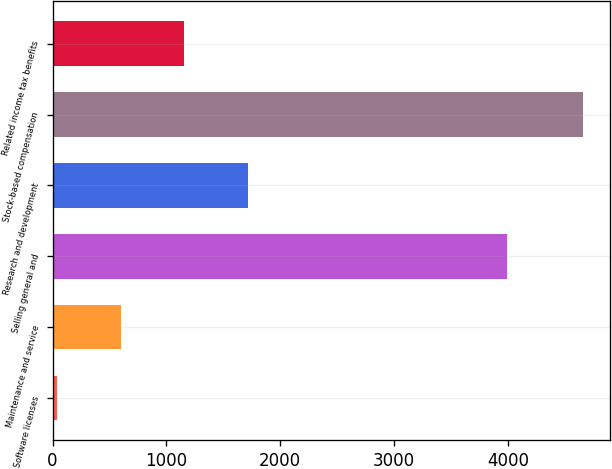Convert chart to OTSL. <chart><loc_0><loc_0><loc_500><loc_500><bar_chart><fcel>Software licenses<fcel>Maintenance and service<fcel>Selling general and<fcel>Research and development<fcel>Stock-based compensation<fcel>Related income tax benefits<nl><fcel>42<fcel>600.4<fcel>3990<fcel>1717.2<fcel>4661<fcel>1158.8<nl></chart> 